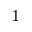Convert formula to latex. <formula><loc_0><loc_0><loc_500><loc_500>^ { 1 }</formula> 